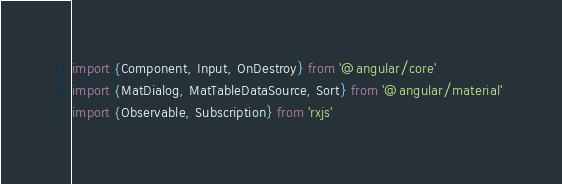Convert code to text. <code><loc_0><loc_0><loc_500><loc_500><_TypeScript_>import {Component, Input, OnDestroy} from '@angular/core'
import {MatDialog, MatTableDataSource, Sort} from '@angular/material'
import {Observable, Subscription} from 'rxjs'</code> 